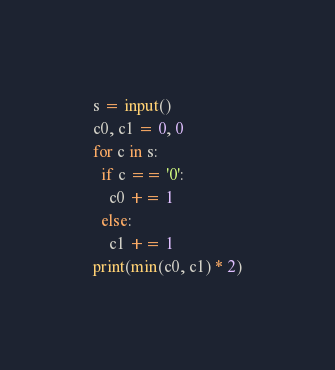<code> <loc_0><loc_0><loc_500><loc_500><_Python_>s = input()
c0, c1 = 0, 0
for c in s:
  if c == '0':
    c0 += 1
  else:
    c1 += 1
print(min(c0, c1) * 2)</code> 